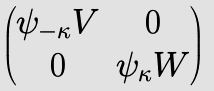<formula> <loc_0><loc_0><loc_500><loc_500>\begin{pmatrix} \psi _ { - \kappa } V & 0 \\ 0 & \psi _ { \kappa } W \end{pmatrix}</formula> 